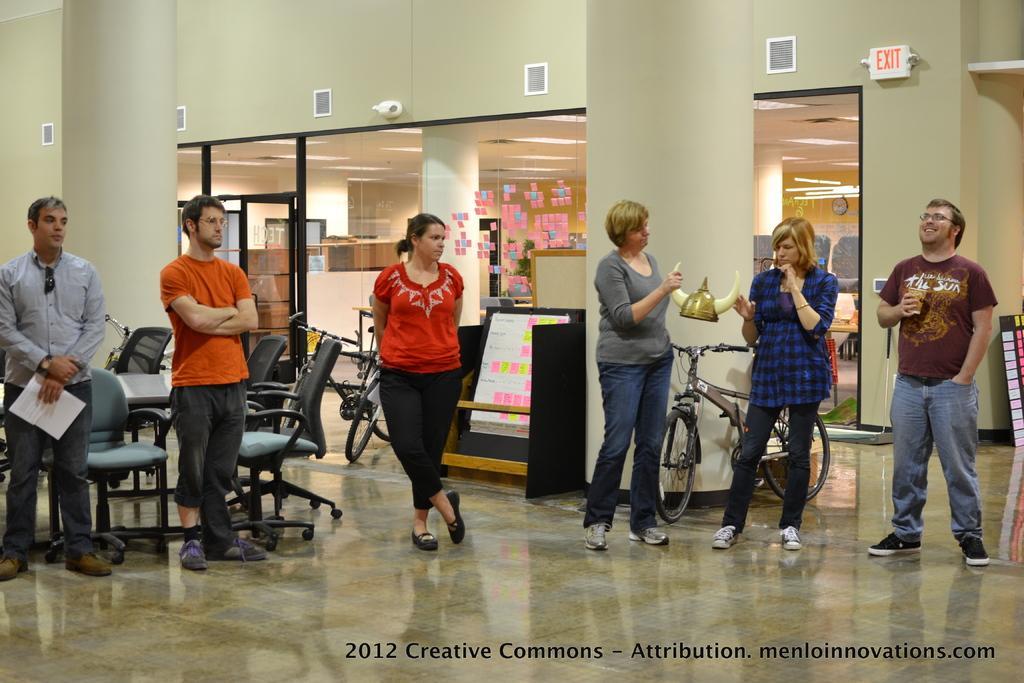Describe this image in one or two sentences. In this picture we can see a sign board, sticky notes, clock, bicycles, objects chairs and table. We can see the people are standing on the floor. On the right side of the picture we can see a man wearing spectacles and holding a glass. We can see the women are holding an object. We can see the sticky notes on the boards. 